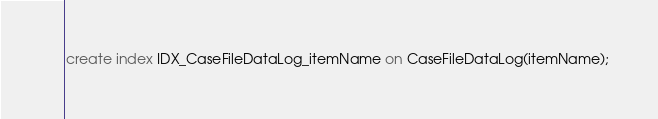Convert code to text. <code><loc_0><loc_0><loc_500><loc_500><_SQL_>create index IDX_CaseFileDataLog_itemName on CaseFileDataLog(itemName);

</code> 